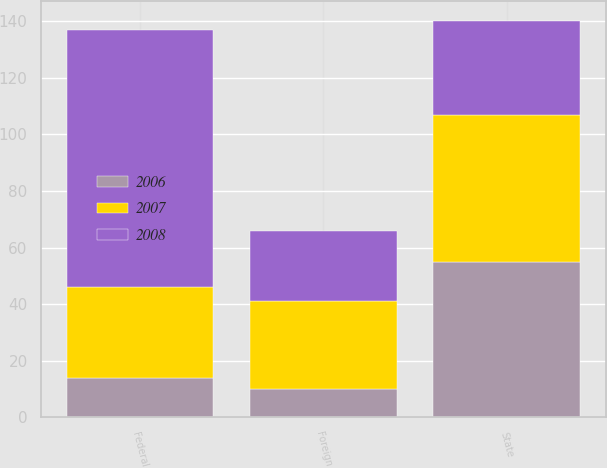<chart> <loc_0><loc_0><loc_500><loc_500><stacked_bar_chart><ecel><fcel>State<fcel>Foreign<fcel>Federal<nl><fcel>2007<fcel>52<fcel>31<fcel>32<nl><fcel>2008<fcel>33<fcel>25<fcel>91<nl><fcel>2006<fcel>55<fcel>10<fcel>14<nl></chart> 